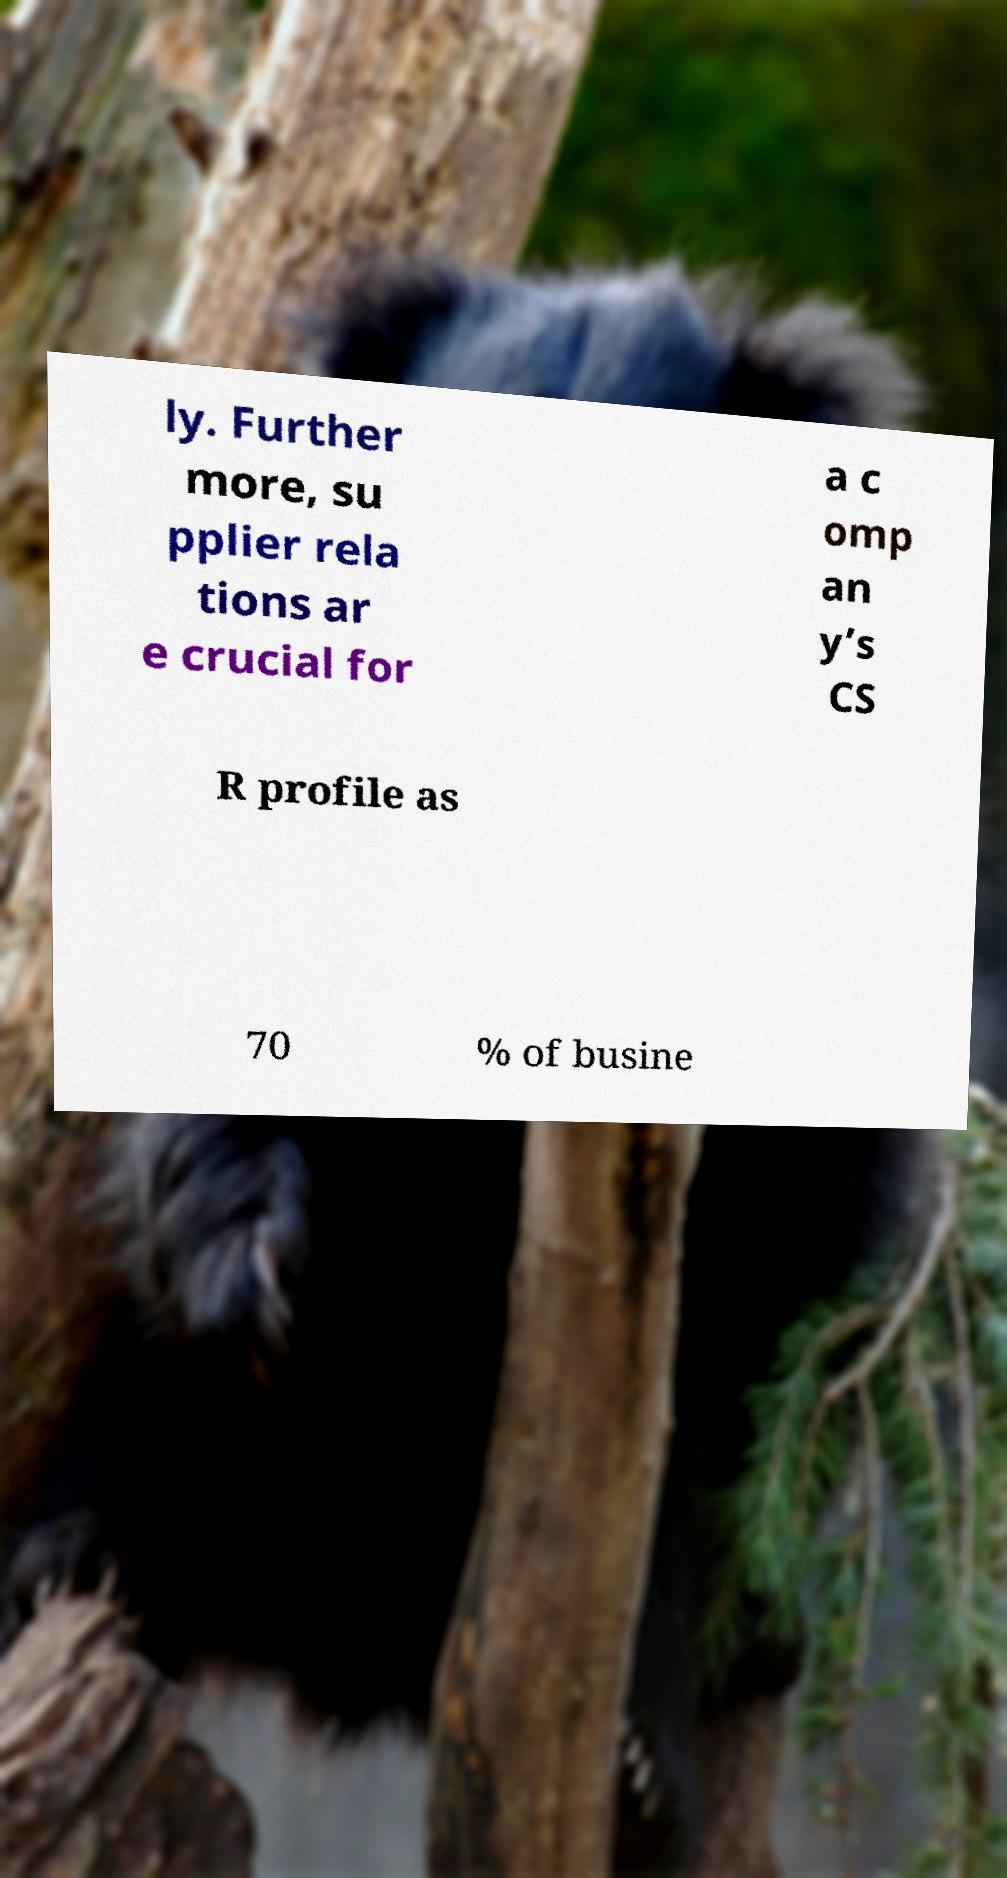Please identify and transcribe the text found in this image. ly. Further more, su pplier rela tions ar e crucial for a c omp an y’s CS R profile as 70 % of busine 